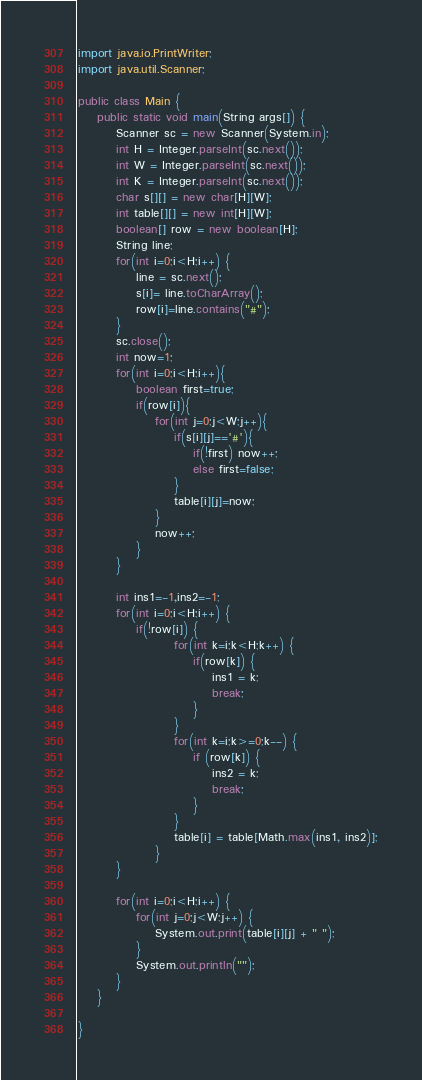<code> <loc_0><loc_0><loc_500><loc_500><_Java_>import java.io.PrintWriter;
import java.util.Scanner;

public class Main {
	public static void main(String args[]) {
		Scanner sc = new Scanner(System.in);
		int H = Integer.parseInt(sc.next());
		int W = Integer.parseInt(sc.next());
		int K = Integer.parseInt(sc.next());
		char s[][] = new char[H][W];
		int table[][] = new int[H][W];
		boolean[] row = new boolean[H];
		String line;
		for(int i=0;i<H;i++) {
			line = sc.next();
            s[i]= line.toCharArray();
            row[i]=line.contains("#");
        }
        sc.close();
        int now=1;
        for(int i=0;i<H;i++){
            boolean first=true;
            if(row[i]){
                for(int j=0;j<W;j++){
                    if(s[i][j]=='#'){
                        if(!first) now++;
                        else first=false;
                    }
                    table[i][j]=now;
                }
                now++;
            }
        }

		int ins1=-1,ins2=-1;
		for(int i=0;i<H;i++) {
			if(!row[i]) {
                    for(int k=i;k<H;k++) {
                        if(row[k]) {
                            ins1 = k;
                            break;
                        }
                    }
                    for(int k=i;k>=0;k--) {
                        if (row[k]) {
                            ins2 = k;
                            break;
                        }
                    }
                    table[i] = table[Math.max(ins1, ins2)];
				}
        }
        
		for(int i=0;i<H;i++) {
			for(int j=0;j<W;j++) {
				System.out.print(table[i][j] + " ");
			}
			System.out.println("");
		}
	}

}
</code> 